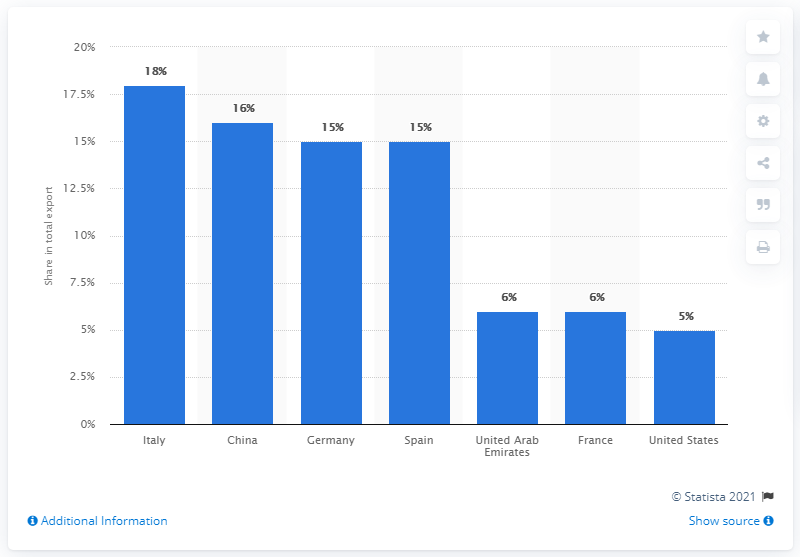List a handful of essential elements in this visual. In 2019, Italy was the most important export partner of Libya. 